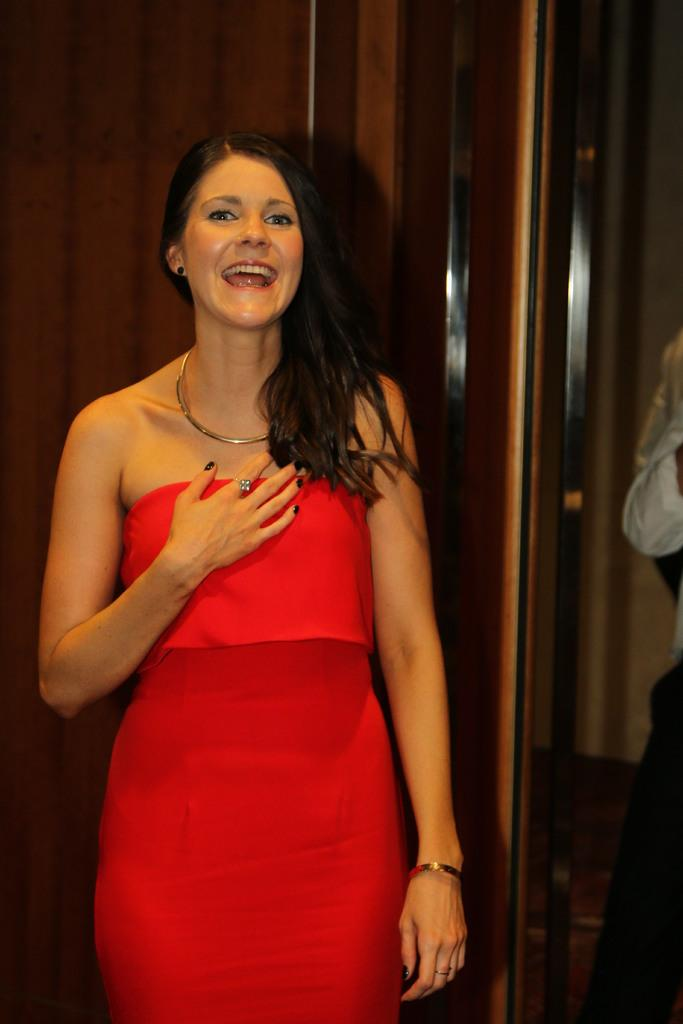What is the primary subject of the image? There is a woman standing in the image. Can you describe the other human in the image? There is another human standing on the right side of the image. What type of doors can be seen in the background of the image? There appear to be wooden doors in the background of the image. What type of instrument can be heard playing in the image? There is no instrument or sound present in the image, as it is a still photograph. 